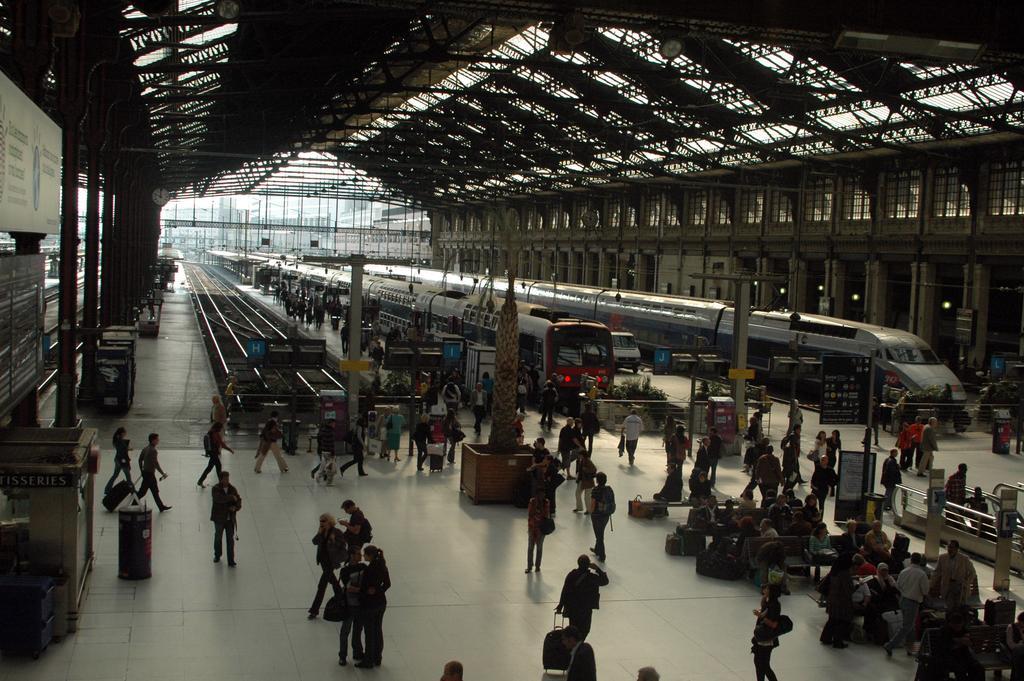How would you summarize this image in a sentence or two? In this picture I can see couple of trains on the railway tracks and I can see couple of railway tracks on the side and I can see few people standing and few people are seated and few people walking. It looks like a railway station. 